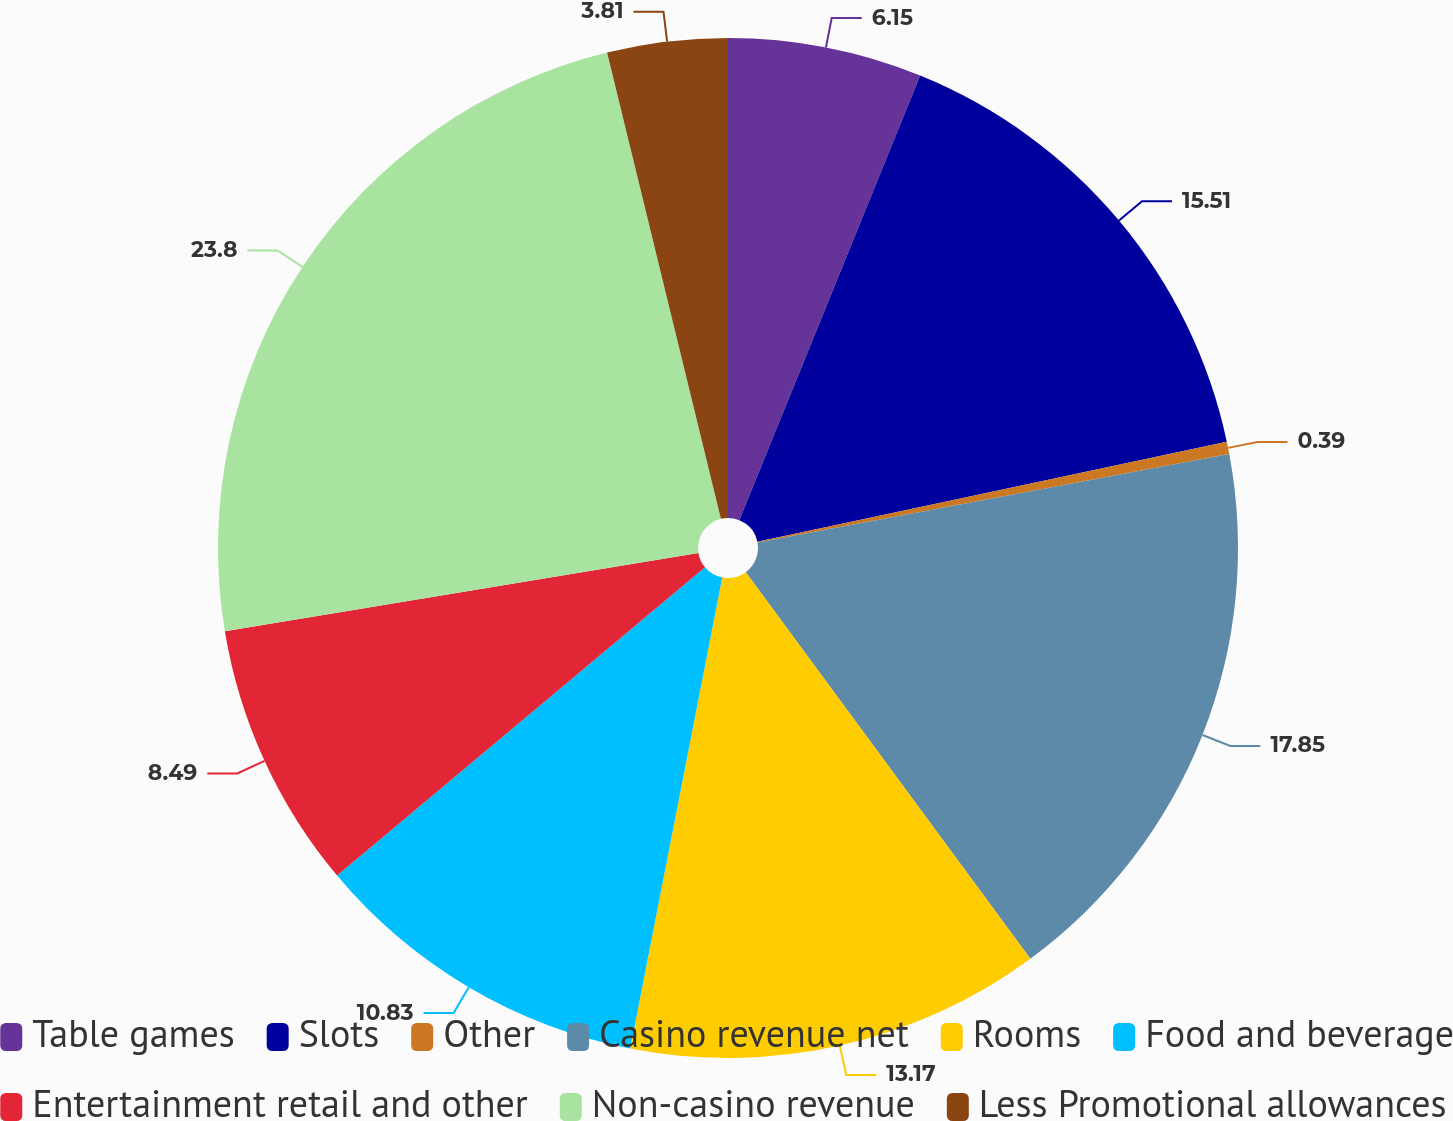<chart> <loc_0><loc_0><loc_500><loc_500><pie_chart><fcel>Table games<fcel>Slots<fcel>Other<fcel>Casino revenue net<fcel>Rooms<fcel>Food and beverage<fcel>Entertainment retail and other<fcel>Non-casino revenue<fcel>Less Promotional allowances<nl><fcel>6.15%<fcel>15.51%<fcel>0.39%<fcel>17.85%<fcel>13.17%<fcel>10.83%<fcel>8.49%<fcel>23.8%<fcel>3.81%<nl></chart> 